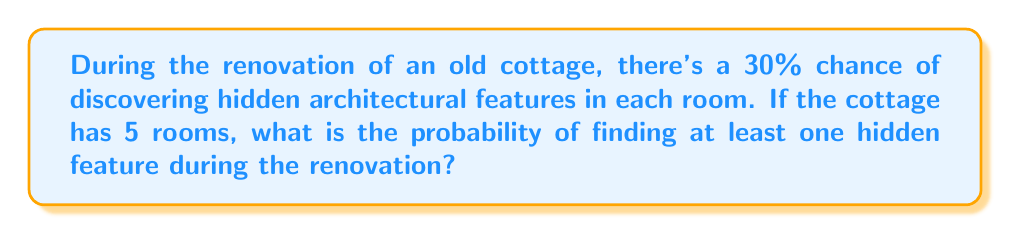Can you solve this math problem? Let's approach this step-by-step:

1) First, let's consider the probability of not finding a hidden feature in a single room. If the probability of finding a feature is 30% or 0.3, then the probability of not finding a feature is:

   $1 - 0.3 = 0.7$ or 70%

2) Now, for the entire cottage to have no hidden features, we need this to be true for all 5 rooms. The probability of this occurring is:

   $0.7^5 = 0.16807$ or about 16.807%

3) Therefore, the probability of finding at least one hidden feature is the opposite of finding no features:

   $1 - 0.16807 = 0.83193$ or about 83.193%

4) We can also calculate this using the complement rule of probability:

   $$P(\text{at least one}) = 1 - P(\text{none})$$
   $$= 1 - (1 - 0.3)^5$$
   $$= 1 - 0.7^5$$
   $$= 0.83193$$

This means there's approximately an 83.193% chance of discovering at least one hidden architectural feature during the renovation of this 5-room cottage.
Answer: 0.83193 or 83.193% 